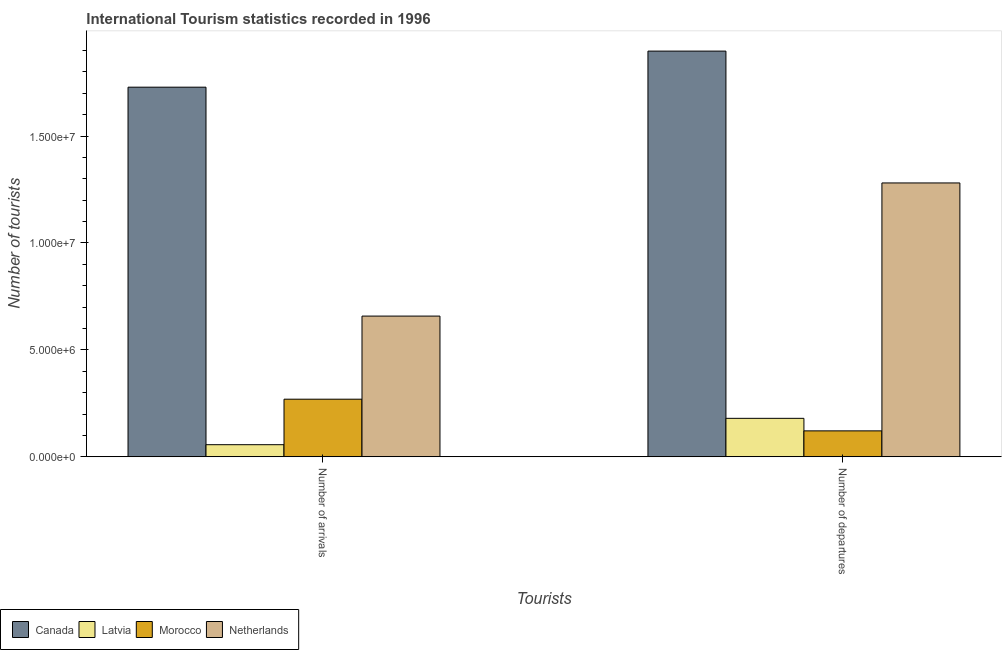How many bars are there on the 1st tick from the left?
Make the answer very short. 4. How many bars are there on the 1st tick from the right?
Keep it short and to the point. 4. What is the label of the 2nd group of bars from the left?
Provide a short and direct response. Number of departures. What is the number of tourist arrivals in Canada?
Make the answer very short. 1.73e+07. Across all countries, what is the maximum number of tourist departures?
Your response must be concise. 1.90e+07. Across all countries, what is the minimum number of tourist arrivals?
Your answer should be compact. 5.65e+05. In which country was the number of tourist departures minimum?
Offer a very short reply. Morocco. What is the total number of tourist departures in the graph?
Offer a terse response. 3.48e+07. What is the difference between the number of tourist arrivals in Netherlands and that in Morocco?
Ensure brevity in your answer.  3.89e+06. What is the difference between the number of tourist arrivals in Canada and the number of tourist departures in Latvia?
Your response must be concise. 1.55e+07. What is the average number of tourist arrivals per country?
Offer a very short reply. 6.78e+06. What is the difference between the number of tourist arrivals and number of tourist departures in Latvia?
Your answer should be compact. -1.23e+06. In how many countries, is the number of tourist departures greater than 10000000 ?
Give a very brief answer. 2. What is the ratio of the number of tourist arrivals in Morocco to that in Canada?
Your answer should be very brief. 0.16. Is the number of tourist departures in Morocco less than that in Latvia?
Offer a very short reply. Yes. What does the 2nd bar from the left in Number of departures represents?
Keep it short and to the point. Latvia. Are all the bars in the graph horizontal?
Ensure brevity in your answer.  No. How many countries are there in the graph?
Offer a very short reply. 4. What is the difference between two consecutive major ticks on the Y-axis?
Give a very brief answer. 5.00e+06. Does the graph contain any zero values?
Give a very brief answer. No. Where does the legend appear in the graph?
Your answer should be very brief. Bottom left. How many legend labels are there?
Your response must be concise. 4. What is the title of the graph?
Ensure brevity in your answer.  International Tourism statistics recorded in 1996. Does "Tanzania" appear as one of the legend labels in the graph?
Your answer should be compact. No. What is the label or title of the X-axis?
Give a very brief answer. Tourists. What is the label or title of the Y-axis?
Offer a very short reply. Number of tourists. What is the Number of tourists in Canada in Number of arrivals?
Provide a succinct answer. 1.73e+07. What is the Number of tourists in Latvia in Number of arrivals?
Provide a succinct answer. 5.65e+05. What is the Number of tourists of Morocco in Number of arrivals?
Provide a short and direct response. 2.69e+06. What is the Number of tourists of Netherlands in Number of arrivals?
Your answer should be very brief. 6.58e+06. What is the Number of tourists in Canada in Number of departures?
Your answer should be compact. 1.90e+07. What is the Number of tourists in Latvia in Number of departures?
Offer a very short reply. 1.80e+06. What is the Number of tourists in Morocco in Number of departures?
Your answer should be very brief. 1.21e+06. What is the Number of tourists of Netherlands in Number of departures?
Offer a very short reply. 1.28e+07. Across all Tourists, what is the maximum Number of tourists of Canada?
Make the answer very short. 1.90e+07. Across all Tourists, what is the maximum Number of tourists of Latvia?
Your response must be concise. 1.80e+06. Across all Tourists, what is the maximum Number of tourists of Morocco?
Provide a succinct answer. 2.69e+06. Across all Tourists, what is the maximum Number of tourists of Netherlands?
Ensure brevity in your answer.  1.28e+07. Across all Tourists, what is the minimum Number of tourists in Canada?
Offer a very short reply. 1.73e+07. Across all Tourists, what is the minimum Number of tourists of Latvia?
Your response must be concise. 5.65e+05. Across all Tourists, what is the minimum Number of tourists in Morocco?
Your answer should be very brief. 1.21e+06. Across all Tourists, what is the minimum Number of tourists of Netherlands?
Make the answer very short. 6.58e+06. What is the total Number of tourists in Canada in the graph?
Give a very brief answer. 3.63e+07. What is the total Number of tourists in Latvia in the graph?
Keep it short and to the point. 2.36e+06. What is the total Number of tourists of Morocco in the graph?
Your response must be concise. 3.90e+06. What is the total Number of tourists of Netherlands in the graph?
Keep it short and to the point. 1.94e+07. What is the difference between the Number of tourists of Canada in Number of arrivals and that in Number of departures?
Ensure brevity in your answer.  -1.69e+06. What is the difference between the Number of tourists in Latvia in Number of arrivals and that in Number of departures?
Your response must be concise. -1.23e+06. What is the difference between the Number of tourists of Morocco in Number of arrivals and that in Number of departures?
Ensure brevity in your answer.  1.48e+06. What is the difference between the Number of tourists in Netherlands in Number of arrivals and that in Number of departures?
Offer a very short reply. -6.23e+06. What is the difference between the Number of tourists in Canada in Number of arrivals and the Number of tourists in Latvia in Number of departures?
Offer a very short reply. 1.55e+07. What is the difference between the Number of tourists of Canada in Number of arrivals and the Number of tourists of Morocco in Number of departures?
Offer a very short reply. 1.61e+07. What is the difference between the Number of tourists in Canada in Number of arrivals and the Number of tourists in Netherlands in Number of departures?
Your answer should be compact. 4.48e+06. What is the difference between the Number of tourists of Latvia in Number of arrivals and the Number of tourists of Morocco in Number of departures?
Your response must be concise. -6.47e+05. What is the difference between the Number of tourists in Latvia in Number of arrivals and the Number of tourists in Netherlands in Number of departures?
Give a very brief answer. -1.22e+07. What is the difference between the Number of tourists in Morocco in Number of arrivals and the Number of tourists in Netherlands in Number of departures?
Provide a succinct answer. -1.01e+07. What is the average Number of tourists of Canada per Tourists?
Provide a succinct answer. 1.81e+07. What is the average Number of tourists in Latvia per Tourists?
Offer a terse response. 1.18e+06. What is the average Number of tourists in Morocco per Tourists?
Make the answer very short. 1.95e+06. What is the average Number of tourists of Netherlands per Tourists?
Ensure brevity in your answer.  9.69e+06. What is the difference between the Number of tourists of Canada and Number of tourists of Latvia in Number of arrivals?
Give a very brief answer. 1.67e+07. What is the difference between the Number of tourists in Canada and Number of tourists in Morocco in Number of arrivals?
Your response must be concise. 1.46e+07. What is the difference between the Number of tourists in Canada and Number of tourists in Netherlands in Number of arrivals?
Offer a terse response. 1.07e+07. What is the difference between the Number of tourists in Latvia and Number of tourists in Morocco in Number of arrivals?
Your response must be concise. -2.13e+06. What is the difference between the Number of tourists in Latvia and Number of tourists in Netherlands in Number of arrivals?
Give a very brief answer. -6.02e+06. What is the difference between the Number of tourists of Morocco and Number of tourists of Netherlands in Number of arrivals?
Ensure brevity in your answer.  -3.89e+06. What is the difference between the Number of tourists in Canada and Number of tourists in Latvia in Number of departures?
Make the answer very short. 1.72e+07. What is the difference between the Number of tourists in Canada and Number of tourists in Morocco in Number of departures?
Your response must be concise. 1.78e+07. What is the difference between the Number of tourists of Canada and Number of tourists of Netherlands in Number of departures?
Your answer should be compact. 6.17e+06. What is the difference between the Number of tourists in Latvia and Number of tourists in Morocco in Number of departures?
Offer a very short reply. 5.86e+05. What is the difference between the Number of tourists in Latvia and Number of tourists in Netherlands in Number of departures?
Your answer should be compact. -1.10e+07. What is the difference between the Number of tourists of Morocco and Number of tourists of Netherlands in Number of departures?
Ensure brevity in your answer.  -1.16e+07. What is the ratio of the Number of tourists in Canada in Number of arrivals to that in Number of departures?
Give a very brief answer. 0.91. What is the ratio of the Number of tourists in Latvia in Number of arrivals to that in Number of departures?
Make the answer very short. 0.31. What is the ratio of the Number of tourists of Morocco in Number of arrivals to that in Number of departures?
Keep it short and to the point. 2.22. What is the ratio of the Number of tourists of Netherlands in Number of arrivals to that in Number of departures?
Your answer should be compact. 0.51. What is the difference between the highest and the second highest Number of tourists in Canada?
Give a very brief answer. 1.69e+06. What is the difference between the highest and the second highest Number of tourists in Latvia?
Offer a terse response. 1.23e+06. What is the difference between the highest and the second highest Number of tourists of Morocco?
Offer a very short reply. 1.48e+06. What is the difference between the highest and the second highest Number of tourists in Netherlands?
Keep it short and to the point. 6.23e+06. What is the difference between the highest and the lowest Number of tourists of Canada?
Offer a very short reply. 1.69e+06. What is the difference between the highest and the lowest Number of tourists in Latvia?
Make the answer very short. 1.23e+06. What is the difference between the highest and the lowest Number of tourists of Morocco?
Keep it short and to the point. 1.48e+06. What is the difference between the highest and the lowest Number of tourists in Netherlands?
Give a very brief answer. 6.23e+06. 